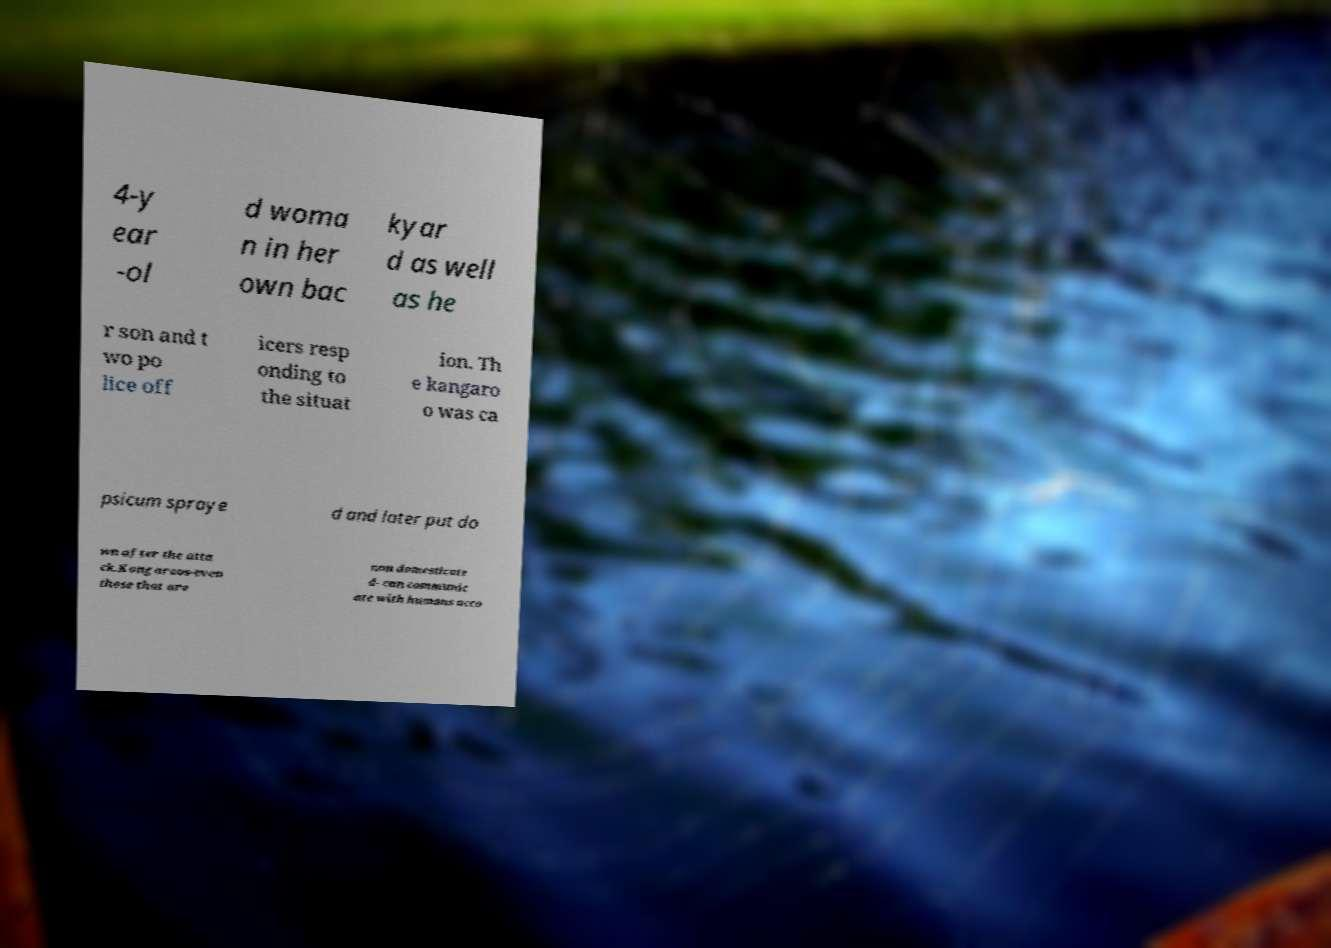Please read and relay the text visible in this image. What does it say? 4-y ear -ol d woma n in her own bac kyar d as well as he r son and t wo po lice off icers resp onding to the situat ion. Th e kangaro o was ca psicum spraye d and later put do wn after the atta ck.Kangaroos-even those that are non domesticate d- can communic ate with humans acco 